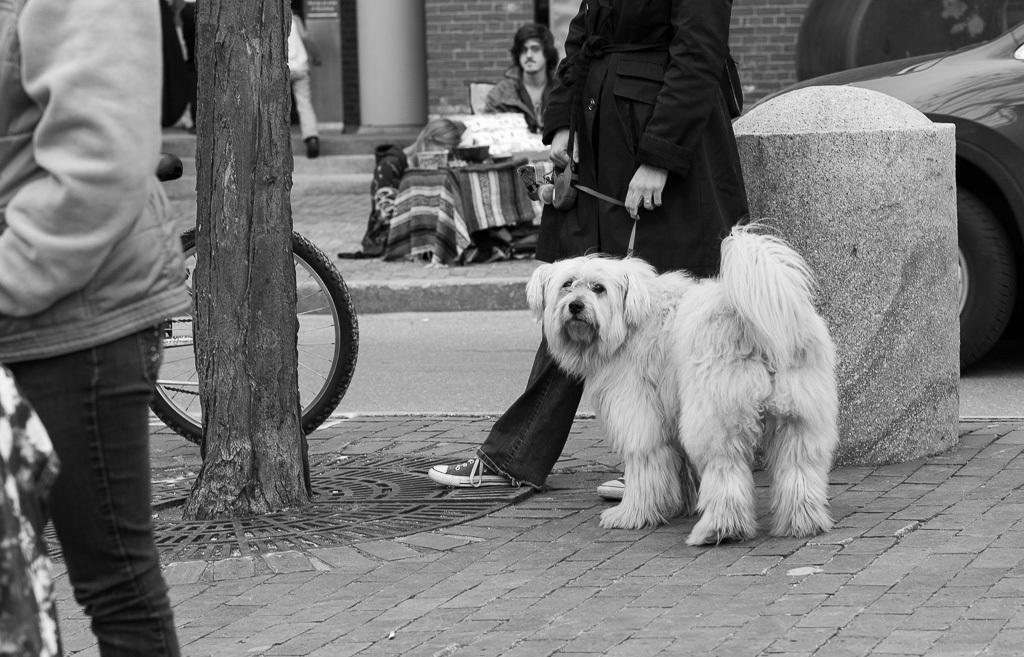Describe this image in one or two sentences. In this image we can see a person sitting on the ground. A person is sitting on the chair. There is a person at the left side of the image. There is a bicycle in the image. There is a vehicle at the right side of the image. There is a building in the image. There is a dog in the image. 